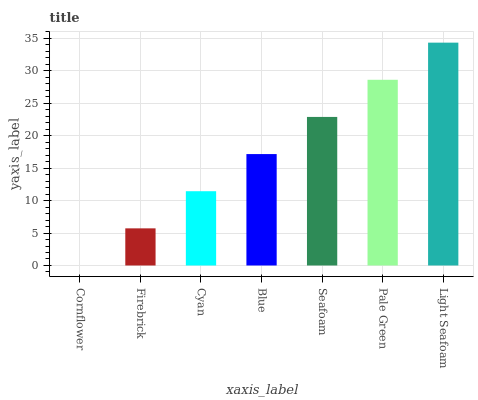Is Cornflower the minimum?
Answer yes or no. Yes. Is Light Seafoam the maximum?
Answer yes or no. Yes. Is Firebrick the minimum?
Answer yes or no. No. Is Firebrick the maximum?
Answer yes or no. No. Is Firebrick greater than Cornflower?
Answer yes or no. Yes. Is Cornflower less than Firebrick?
Answer yes or no. Yes. Is Cornflower greater than Firebrick?
Answer yes or no. No. Is Firebrick less than Cornflower?
Answer yes or no. No. Is Blue the high median?
Answer yes or no. Yes. Is Blue the low median?
Answer yes or no. Yes. Is Seafoam the high median?
Answer yes or no. No. Is Cyan the low median?
Answer yes or no. No. 